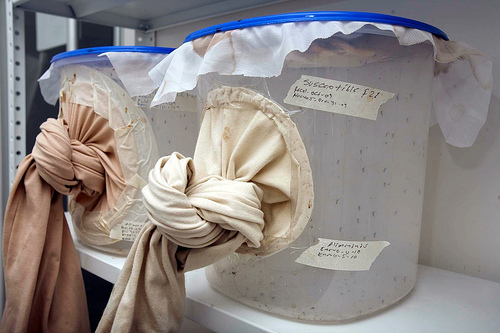<image>
Is the bucket under the wall? No. The bucket is not positioned under the wall. The vertical relationship between these objects is different. 